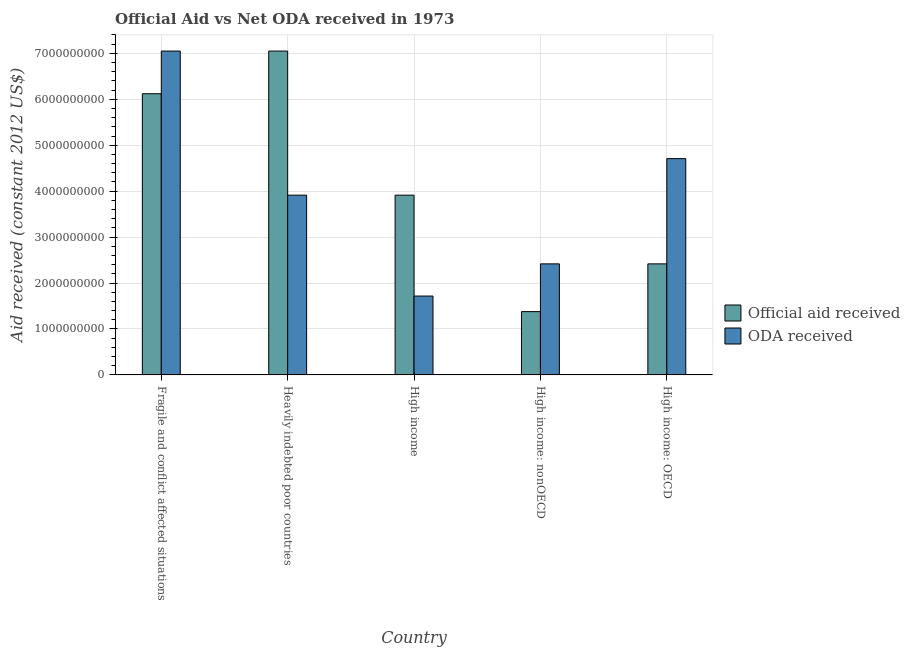How many bars are there on the 4th tick from the left?
Provide a succinct answer. 2. What is the label of the 5th group of bars from the left?
Offer a very short reply. High income: OECD. What is the oda received in Fragile and conflict affected situations?
Ensure brevity in your answer.  7.05e+09. Across all countries, what is the maximum official aid received?
Offer a terse response. 7.05e+09. Across all countries, what is the minimum official aid received?
Keep it short and to the point. 1.38e+09. In which country was the oda received maximum?
Keep it short and to the point. Fragile and conflict affected situations. In which country was the official aid received minimum?
Ensure brevity in your answer.  High income: nonOECD. What is the total oda received in the graph?
Provide a short and direct response. 1.98e+1. What is the difference between the oda received in Fragile and conflict affected situations and that in High income?
Provide a short and direct response. 5.33e+09. What is the difference between the oda received in High income: nonOECD and the official aid received in High income?
Provide a short and direct response. -1.50e+09. What is the average oda received per country?
Provide a succinct answer. 3.96e+09. What is the difference between the official aid received and oda received in Heavily indebted poor countries?
Offer a terse response. 3.14e+09. What is the ratio of the oda received in Heavily indebted poor countries to that in High income: nonOECD?
Offer a very short reply. 1.62. Is the difference between the oda received in High income and High income: OECD greater than the difference between the official aid received in High income and High income: OECD?
Your answer should be very brief. No. What is the difference between the highest and the second highest oda received?
Keep it short and to the point. 2.34e+09. What is the difference between the highest and the lowest official aid received?
Your answer should be compact. 5.67e+09. Is the sum of the oda received in High income and High income: OECD greater than the maximum official aid received across all countries?
Provide a short and direct response. No. What does the 1st bar from the left in High income represents?
Make the answer very short. Official aid received. What does the 2nd bar from the right in Heavily indebted poor countries represents?
Make the answer very short. Official aid received. How many bars are there?
Your answer should be very brief. 10. Are all the bars in the graph horizontal?
Your response must be concise. No. How many countries are there in the graph?
Give a very brief answer. 5. Does the graph contain any zero values?
Give a very brief answer. No. Does the graph contain grids?
Provide a short and direct response. Yes. Where does the legend appear in the graph?
Your answer should be very brief. Center right. How are the legend labels stacked?
Your answer should be very brief. Vertical. What is the title of the graph?
Offer a terse response. Official Aid vs Net ODA received in 1973 . What is the label or title of the Y-axis?
Ensure brevity in your answer.  Aid received (constant 2012 US$). What is the Aid received (constant 2012 US$) in Official aid received in Fragile and conflict affected situations?
Your response must be concise. 6.12e+09. What is the Aid received (constant 2012 US$) in ODA received in Fragile and conflict affected situations?
Your answer should be very brief. 7.05e+09. What is the Aid received (constant 2012 US$) of Official aid received in Heavily indebted poor countries?
Ensure brevity in your answer.  7.05e+09. What is the Aid received (constant 2012 US$) in ODA received in Heavily indebted poor countries?
Keep it short and to the point. 3.91e+09. What is the Aid received (constant 2012 US$) of Official aid received in High income?
Offer a terse response. 3.91e+09. What is the Aid received (constant 2012 US$) in ODA received in High income?
Make the answer very short. 1.72e+09. What is the Aid received (constant 2012 US$) in Official aid received in High income: nonOECD?
Offer a very short reply. 1.38e+09. What is the Aid received (constant 2012 US$) of ODA received in High income: nonOECD?
Ensure brevity in your answer.  2.42e+09. What is the Aid received (constant 2012 US$) of Official aid received in High income: OECD?
Your answer should be very brief. 2.42e+09. What is the Aid received (constant 2012 US$) in ODA received in High income: OECD?
Provide a short and direct response. 4.71e+09. Across all countries, what is the maximum Aid received (constant 2012 US$) of Official aid received?
Offer a terse response. 7.05e+09. Across all countries, what is the maximum Aid received (constant 2012 US$) in ODA received?
Make the answer very short. 7.05e+09. Across all countries, what is the minimum Aid received (constant 2012 US$) of Official aid received?
Offer a terse response. 1.38e+09. Across all countries, what is the minimum Aid received (constant 2012 US$) in ODA received?
Offer a very short reply. 1.72e+09. What is the total Aid received (constant 2012 US$) of Official aid received in the graph?
Give a very brief answer. 2.09e+1. What is the total Aid received (constant 2012 US$) in ODA received in the graph?
Give a very brief answer. 1.98e+1. What is the difference between the Aid received (constant 2012 US$) of Official aid received in Fragile and conflict affected situations and that in Heavily indebted poor countries?
Your answer should be compact. -9.29e+08. What is the difference between the Aid received (constant 2012 US$) of ODA received in Fragile and conflict affected situations and that in Heavily indebted poor countries?
Offer a terse response. 3.14e+09. What is the difference between the Aid received (constant 2012 US$) of Official aid received in Fragile and conflict affected situations and that in High income?
Keep it short and to the point. 2.21e+09. What is the difference between the Aid received (constant 2012 US$) in ODA received in Fragile and conflict affected situations and that in High income?
Your response must be concise. 5.33e+09. What is the difference between the Aid received (constant 2012 US$) in Official aid received in Fragile and conflict affected situations and that in High income: nonOECD?
Offer a very short reply. 4.74e+09. What is the difference between the Aid received (constant 2012 US$) in ODA received in Fragile and conflict affected situations and that in High income: nonOECD?
Offer a terse response. 4.63e+09. What is the difference between the Aid received (constant 2012 US$) of Official aid received in Fragile and conflict affected situations and that in High income: OECD?
Ensure brevity in your answer.  3.70e+09. What is the difference between the Aid received (constant 2012 US$) in ODA received in Fragile and conflict affected situations and that in High income: OECD?
Your response must be concise. 2.34e+09. What is the difference between the Aid received (constant 2012 US$) in Official aid received in Heavily indebted poor countries and that in High income?
Provide a succinct answer. 3.14e+09. What is the difference between the Aid received (constant 2012 US$) in ODA received in Heavily indebted poor countries and that in High income?
Your response must be concise. 2.20e+09. What is the difference between the Aid received (constant 2012 US$) of Official aid received in Heavily indebted poor countries and that in High income: nonOECD?
Give a very brief answer. 5.67e+09. What is the difference between the Aid received (constant 2012 US$) in ODA received in Heavily indebted poor countries and that in High income: nonOECD?
Your response must be concise. 1.50e+09. What is the difference between the Aid received (constant 2012 US$) in Official aid received in Heavily indebted poor countries and that in High income: OECD?
Your answer should be very brief. 4.63e+09. What is the difference between the Aid received (constant 2012 US$) in ODA received in Heavily indebted poor countries and that in High income: OECD?
Give a very brief answer. -7.95e+08. What is the difference between the Aid received (constant 2012 US$) of Official aid received in High income and that in High income: nonOECD?
Provide a succinct answer. 2.53e+09. What is the difference between the Aid received (constant 2012 US$) of ODA received in High income and that in High income: nonOECD?
Your answer should be very brief. -7.01e+08. What is the difference between the Aid received (constant 2012 US$) of Official aid received in High income and that in High income: OECD?
Offer a terse response. 1.50e+09. What is the difference between the Aid received (constant 2012 US$) of ODA received in High income and that in High income: OECD?
Provide a succinct answer. -2.99e+09. What is the difference between the Aid received (constant 2012 US$) in Official aid received in High income: nonOECD and that in High income: OECD?
Offer a very short reply. -1.04e+09. What is the difference between the Aid received (constant 2012 US$) of ODA received in High income: nonOECD and that in High income: OECD?
Offer a very short reply. -2.29e+09. What is the difference between the Aid received (constant 2012 US$) of Official aid received in Fragile and conflict affected situations and the Aid received (constant 2012 US$) of ODA received in Heavily indebted poor countries?
Ensure brevity in your answer.  2.21e+09. What is the difference between the Aid received (constant 2012 US$) in Official aid received in Fragile and conflict affected situations and the Aid received (constant 2012 US$) in ODA received in High income?
Your response must be concise. 4.40e+09. What is the difference between the Aid received (constant 2012 US$) of Official aid received in Fragile and conflict affected situations and the Aid received (constant 2012 US$) of ODA received in High income: nonOECD?
Ensure brevity in your answer.  3.70e+09. What is the difference between the Aid received (constant 2012 US$) in Official aid received in Fragile and conflict affected situations and the Aid received (constant 2012 US$) in ODA received in High income: OECD?
Provide a short and direct response. 1.41e+09. What is the difference between the Aid received (constant 2012 US$) in Official aid received in Heavily indebted poor countries and the Aid received (constant 2012 US$) in ODA received in High income?
Your answer should be very brief. 5.33e+09. What is the difference between the Aid received (constant 2012 US$) in Official aid received in Heavily indebted poor countries and the Aid received (constant 2012 US$) in ODA received in High income: nonOECD?
Give a very brief answer. 4.63e+09. What is the difference between the Aid received (constant 2012 US$) in Official aid received in Heavily indebted poor countries and the Aid received (constant 2012 US$) in ODA received in High income: OECD?
Your answer should be very brief. 2.34e+09. What is the difference between the Aid received (constant 2012 US$) in Official aid received in High income and the Aid received (constant 2012 US$) in ODA received in High income: nonOECD?
Offer a very short reply. 1.50e+09. What is the difference between the Aid received (constant 2012 US$) of Official aid received in High income and the Aid received (constant 2012 US$) of ODA received in High income: OECD?
Offer a terse response. -7.95e+08. What is the difference between the Aid received (constant 2012 US$) of Official aid received in High income: nonOECD and the Aid received (constant 2012 US$) of ODA received in High income: OECD?
Your answer should be very brief. -3.33e+09. What is the average Aid received (constant 2012 US$) of Official aid received per country?
Give a very brief answer. 4.18e+09. What is the average Aid received (constant 2012 US$) in ODA received per country?
Give a very brief answer. 3.96e+09. What is the difference between the Aid received (constant 2012 US$) in Official aid received and Aid received (constant 2012 US$) in ODA received in Fragile and conflict affected situations?
Provide a succinct answer. -9.29e+08. What is the difference between the Aid received (constant 2012 US$) of Official aid received and Aid received (constant 2012 US$) of ODA received in Heavily indebted poor countries?
Provide a short and direct response. 3.14e+09. What is the difference between the Aid received (constant 2012 US$) in Official aid received and Aid received (constant 2012 US$) in ODA received in High income?
Provide a succinct answer. 2.20e+09. What is the difference between the Aid received (constant 2012 US$) in Official aid received and Aid received (constant 2012 US$) in ODA received in High income: nonOECD?
Provide a succinct answer. -1.04e+09. What is the difference between the Aid received (constant 2012 US$) in Official aid received and Aid received (constant 2012 US$) in ODA received in High income: OECD?
Ensure brevity in your answer.  -2.29e+09. What is the ratio of the Aid received (constant 2012 US$) in Official aid received in Fragile and conflict affected situations to that in Heavily indebted poor countries?
Offer a terse response. 0.87. What is the ratio of the Aid received (constant 2012 US$) of ODA received in Fragile and conflict affected situations to that in Heavily indebted poor countries?
Make the answer very short. 1.8. What is the ratio of the Aid received (constant 2012 US$) in Official aid received in Fragile and conflict affected situations to that in High income?
Your response must be concise. 1.56. What is the ratio of the Aid received (constant 2012 US$) of ODA received in Fragile and conflict affected situations to that in High income?
Give a very brief answer. 4.11. What is the ratio of the Aid received (constant 2012 US$) of Official aid received in Fragile and conflict affected situations to that in High income: nonOECD?
Your response must be concise. 4.44. What is the ratio of the Aid received (constant 2012 US$) in ODA received in Fragile and conflict affected situations to that in High income: nonOECD?
Keep it short and to the point. 2.92. What is the ratio of the Aid received (constant 2012 US$) in Official aid received in Fragile and conflict affected situations to that in High income: OECD?
Keep it short and to the point. 2.53. What is the ratio of the Aid received (constant 2012 US$) of ODA received in Fragile and conflict affected situations to that in High income: OECD?
Provide a short and direct response. 1.5. What is the ratio of the Aid received (constant 2012 US$) in Official aid received in Heavily indebted poor countries to that in High income?
Provide a short and direct response. 1.8. What is the ratio of the Aid received (constant 2012 US$) in ODA received in Heavily indebted poor countries to that in High income?
Offer a very short reply. 2.28. What is the ratio of the Aid received (constant 2012 US$) of Official aid received in Heavily indebted poor countries to that in High income: nonOECD?
Ensure brevity in your answer.  5.12. What is the ratio of the Aid received (constant 2012 US$) in ODA received in Heavily indebted poor countries to that in High income: nonOECD?
Offer a terse response. 1.62. What is the ratio of the Aid received (constant 2012 US$) in Official aid received in Heavily indebted poor countries to that in High income: OECD?
Ensure brevity in your answer.  2.92. What is the ratio of the Aid received (constant 2012 US$) of ODA received in Heavily indebted poor countries to that in High income: OECD?
Your answer should be compact. 0.83. What is the ratio of the Aid received (constant 2012 US$) in Official aid received in High income to that in High income: nonOECD?
Your response must be concise. 2.84. What is the ratio of the Aid received (constant 2012 US$) of ODA received in High income to that in High income: nonOECD?
Provide a short and direct response. 0.71. What is the ratio of the Aid received (constant 2012 US$) of Official aid received in High income to that in High income: OECD?
Make the answer very short. 1.62. What is the ratio of the Aid received (constant 2012 US$) in ODA received in High income to that in High income: OECD?
Ensure brevity in your answer.  0.36. What is the ratio of the Aid received (constant 2012 US$) of Official aid received in High income: nonOECD to that in High income: OECD?
Ensure brevity in your answer.  0.57. What is the ratio of the Aid received (constant 2012 US$) of ODA received in High income: nonOECD to that in High income: OECD?
Offer a very short reply. 0.51. What is the difference between the highest and the second highest Aid received (constant 2012 US$) in Official aid received?
Offer a terse response. 9.29e+08. What is the difference between the highest and the second highest Aid received (constant 2012 US$) in ODA received?
Provide a succinct answer. 2.34e+09. What is the difference between the highest and the lowest Aid received (constant 2012 US$) in Official aid received?
Offer a terse response. 5.67e+09. What is the difference between the highest and the lowest Aid received (constant 2012 US$) in ODA received?
Make the answer very short. 5.33e+09. 